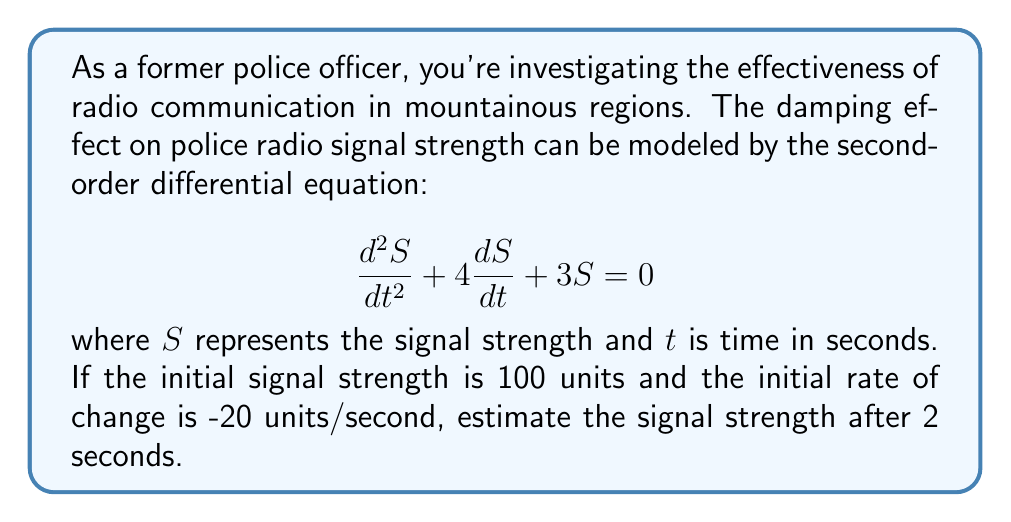Could you help me with this problem? To solve this problem, we need to follow these steps:

1) The general solution for this second-order linear differential equation is:

   $$S(t) = c_1e^{-t} + c_2e^{-3t}$$

2) We need to find $c_1$ and $c_2$ using the initial conditions:
   
   At $t=0$, $S(0) = 100$ and $S'(0) = -20$

3) Using $S(0) = 100$:

   $$100 = c_1 + c_2$$

4) Taking the derivative of $S(t)$:

   $$S'(t) = -c_1e^{-t} - 3c_2e^{-3t}$$

   At $t=0$, $S'(0) = -20$:

   $$-20 = -c_1 - 3c_2$$

5) Now we have a system of equations:

   $$c_1 + c_2 = 100$$
   $$c_1 + 3c_2 = 20$$

6) Subtracting the second equation from the first:

   $$-2c_2 = 80$$
   $$c_2 = -40$$

   Substituting back:

   $$c_1 = 140$$

7) Our particular solution is:

   $$S(t) = 140e^{-t} - 40e^{-3t}$$

8) To find the signal strength at $t=2$:

   $$S(2) = 140e^{-2} - 40e^{-6}$$

9) Calculating this:

   $$S(2) \approx 18.94 - 0.01 \approx 18.93$$

Therefore, after 2 seconds, the estimated signal strength is approximately 18.93 units.
Answer: 18.93 units 